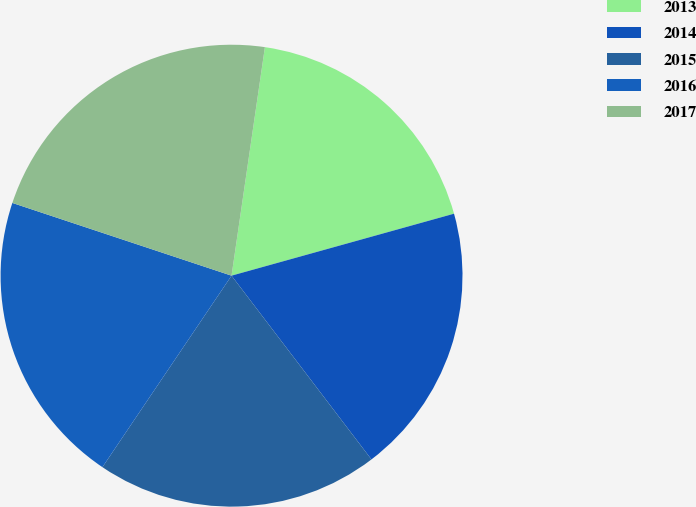<chart> <loc_0><loc_0><loc_500><loc_500><pie_chart><fcel>2013<fcel>2014<fcel>2015<fcel>2016<fcel>2017<nl><fcel>18.37%<fcel>18.97%<fcel>19.8%<fcel>20.66%<fcel>22.21%<nl></chart> 